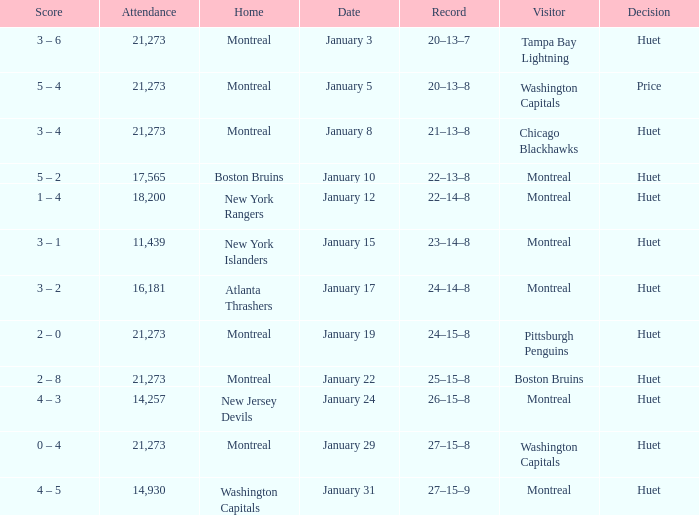What was the score of the game when the Boston Bruins were the visiting team? 2 – 8. 